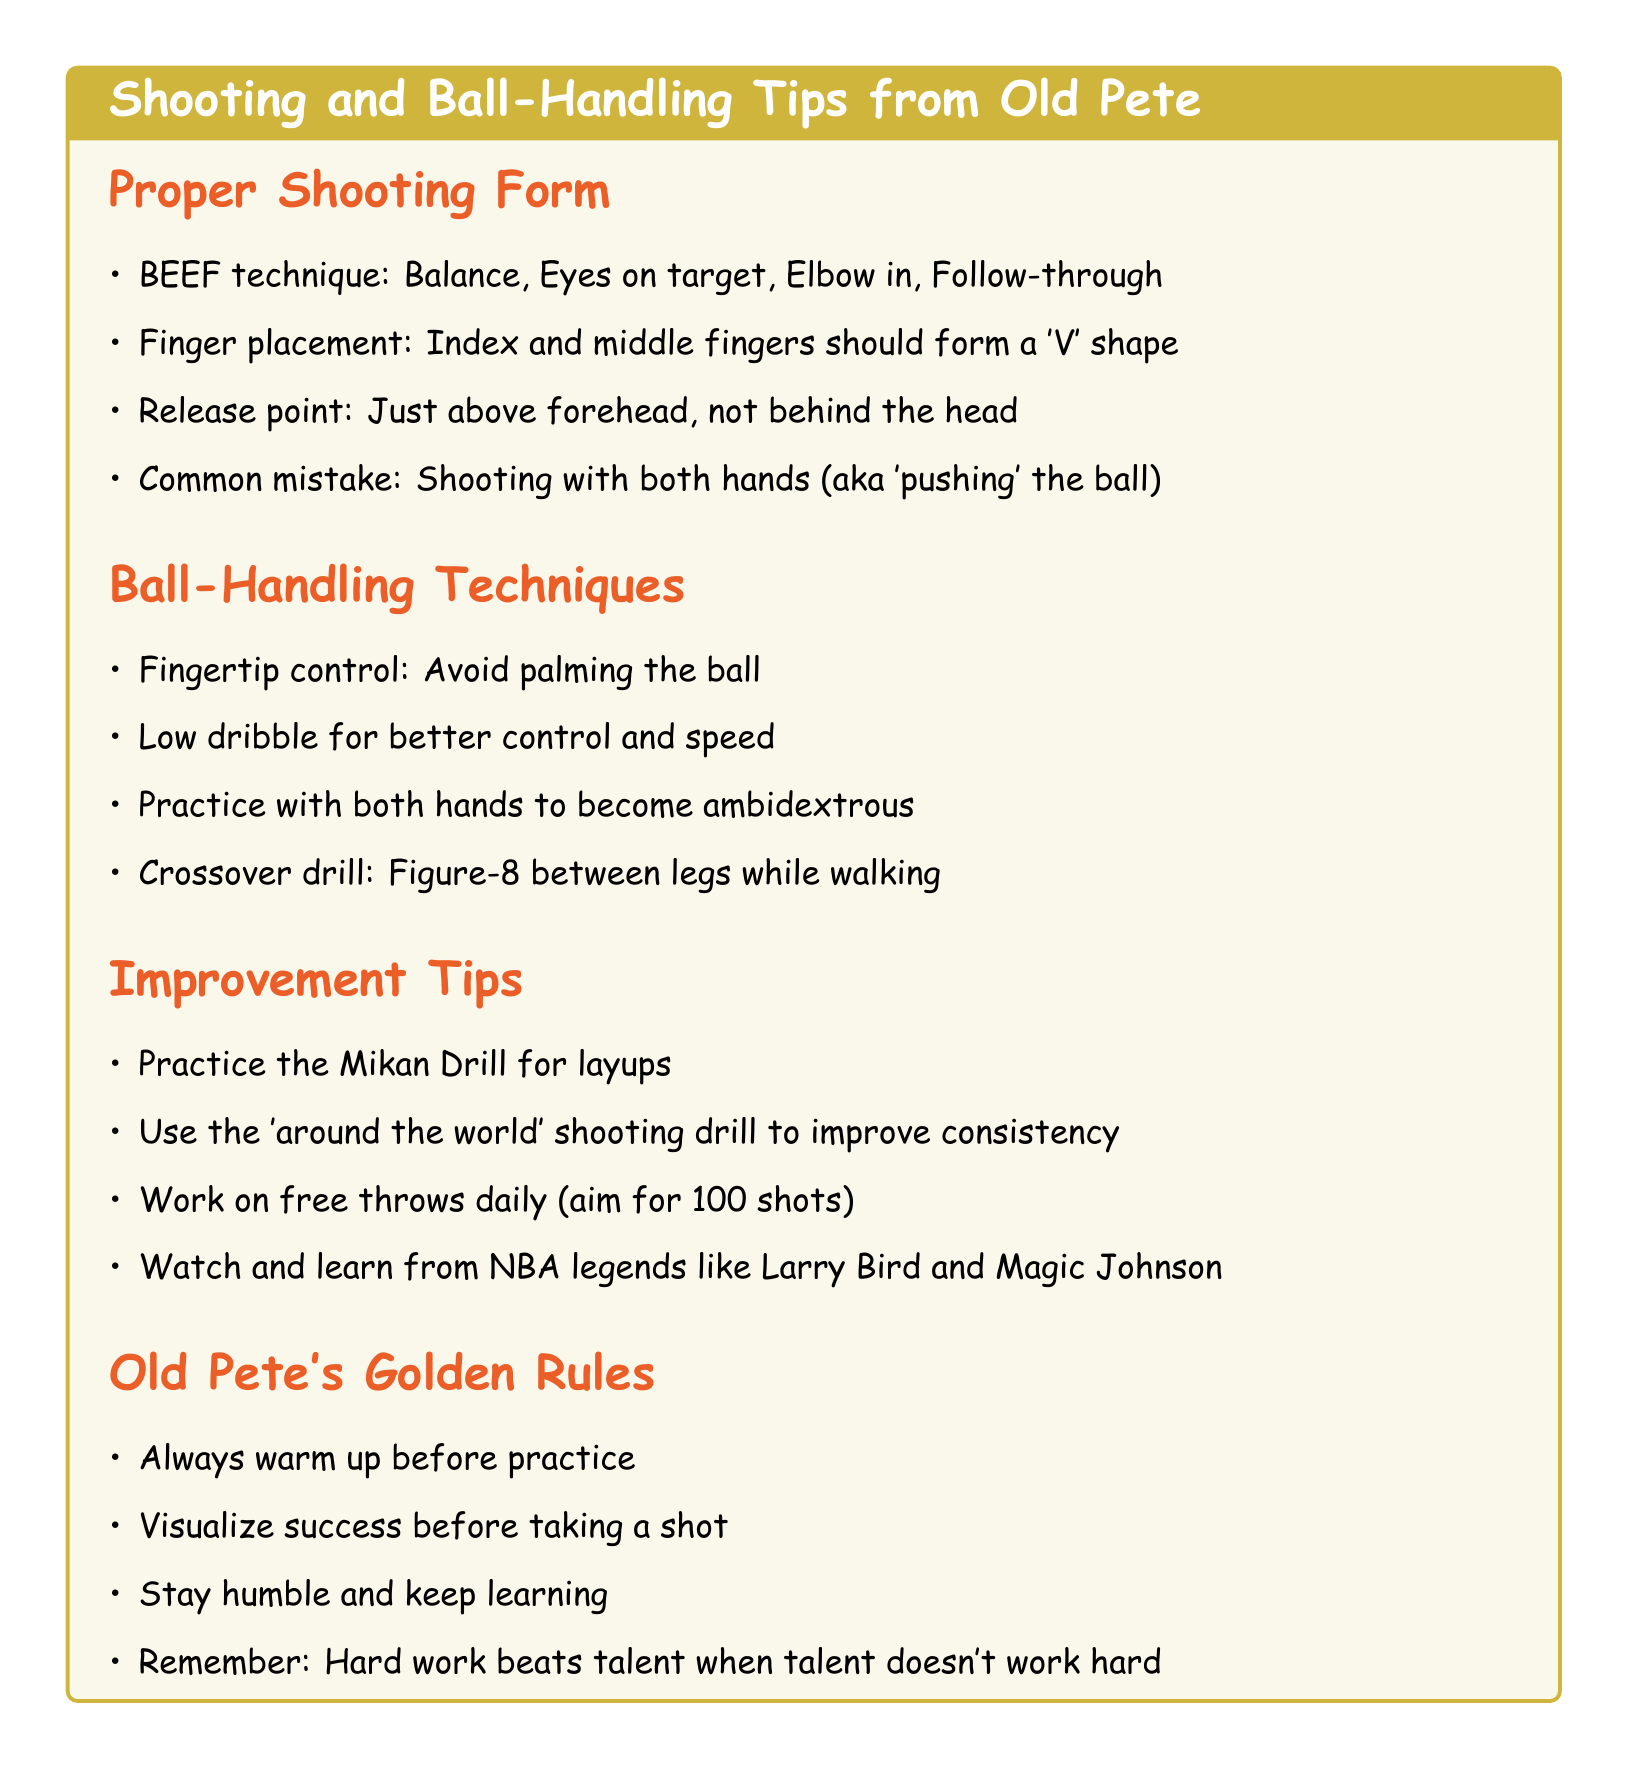What does BEEF stand for? BEEF is an acronym for the components of proper shooting form, which are Balance, Eyes on target, Elbow in, and Follow-through.
Answer: Balance, Eyes on target, Elbow in, Follow-through What is a common shooting mistake? The document mentions a common mistake in shooting as using both hands (referred to as 'pushing' the ball).
Answer: Shooting with both hands What should finger placement form when shooting? The notes specify that the index and middle fingers should create a 'V' shape when placed on the ball for shooting.
Answer: 'V' shape What is a recommended drill for improving layups? The document advises practicing the Mikan Drill to enhance layup skills.
Answer: Mikan Drill How many free throws should you aim for daily? The notes suggest aiming for 100 shots of free throws daily to improve consistency.
Answer: 100 shots What should you do before taking a shot? The document highlights the importance of visualizing success before executing a shot.
Answer: Visualize success Which basketball legends are suggested for learning? The notes recommend watching and learning from NBA legends like Larry Bird and Magic Johnson for skill improvement.
Answer: Larry Bird and Magic Johnson What type of dribble is advised for better control? The document recommends using a low dribble to enhance control and speed while handling the ball.
Answer: Low dribble How many points are covered under Old Pete's Golden Rules? There are four points listed under Old Pete's Golden Rules.
Answer: Four points 